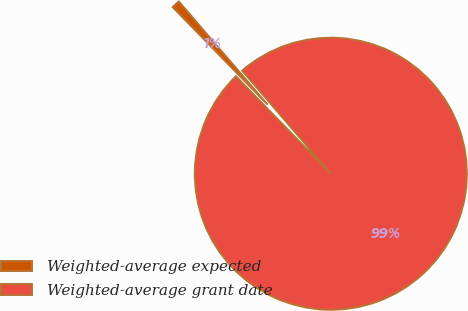Convert chart to OTSL. <chart><loc_0><loc_0><loc_500><loc_500><pie_chart><fcel>Weighted-average expected<fcel>Weighted-average grant date<nl><fcel>0.98%<fcel>99.02%<nl></chart> 